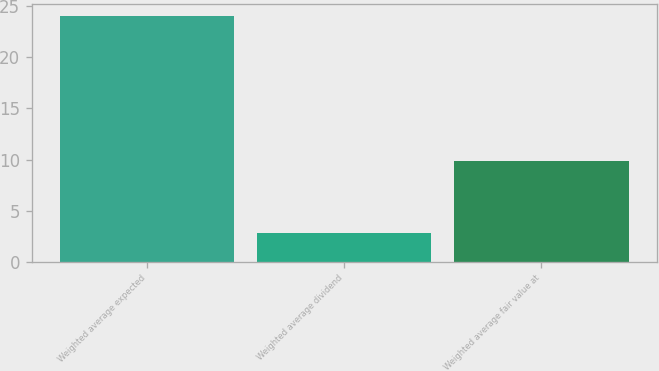Convert chart to OTSL. <chart><loc_0><loc_0><loc_500><loc_500><bar_chart><fcel>Weighted average expected<fcel>Weighted average dividend<fcel>Weighted average fair value at<nl><fcel>24<fcel>2.8<fcel>9.9<nl></chart> 